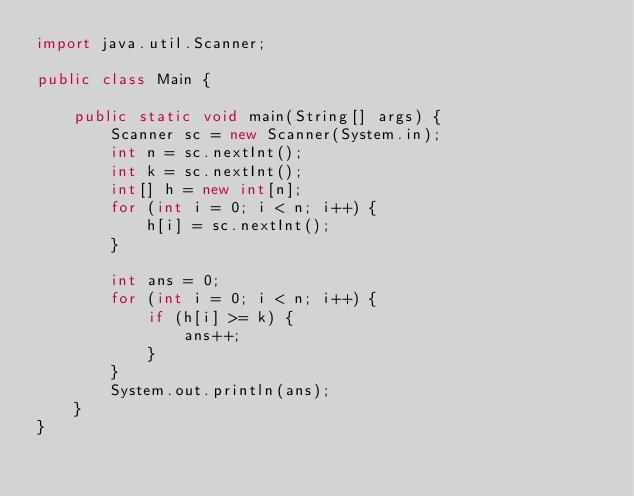Convert code to text. <code><loc_0><loc_0><loc_500><loc_500><_Java_>import java.util.Scanner;

public class Main {

    public static void main(String[] args) {
        Scanner sc = new Scanner(System.in);
        int n = sc.nextInt();
        int k = sc.nextInt();
        int[] h = new int[n];
        for (int i = 0; i < n; i++) {
            h[i] = sc.nextInt();
        }

        int ans = 0;
        for (int i = 0; i < n; i++) {
            if (h[i] >= k) {
                ans++;
            }
        }
        System.out.println(ans);
    }
}
</code> 